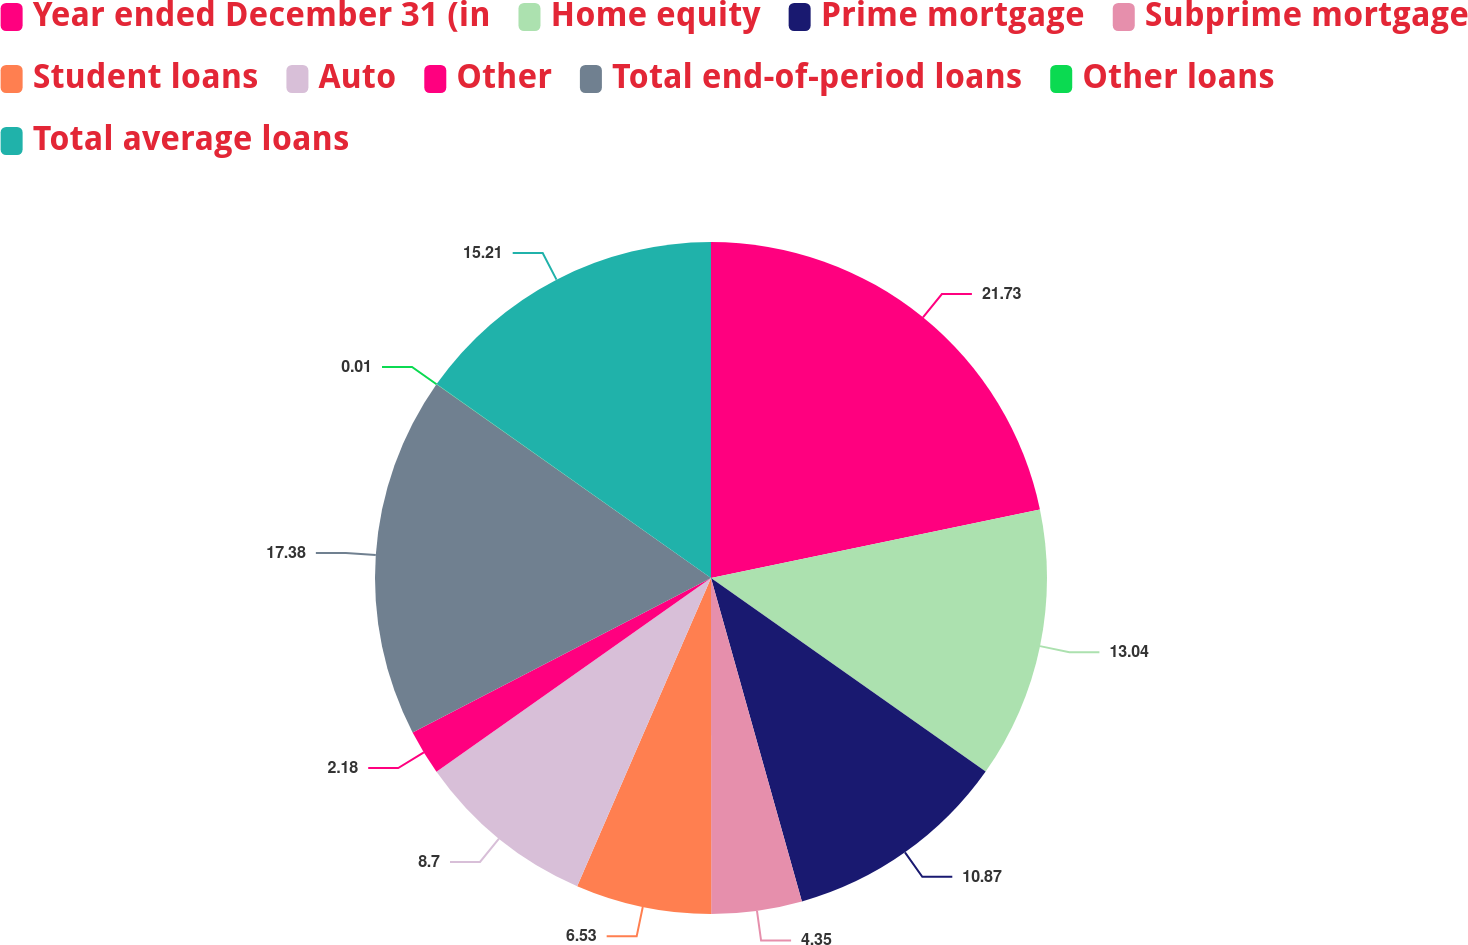Convert chart. <chart><loc_0><loc_0><loc_500><loc_500><pie_chart><fcel>Year ended December 31 (in<fcel>Home equity<fcel>Prime mortgage<fcel>Subprime mortgage<fcel>Student loans<fcel>Auto<fcel>Other<fcel>Total end-of-period loans<fcel>Other loans<fcel>Total average loans<nl><fcel>21.73%<fcel>13.04%<fcel>10.87%<fcel>4.35%<fcel>6.53%<fcel>8.7%<fcel>2.18%<fcel>17.38%<fcel>0.01%<fcel>15.21%<nl></chart> 